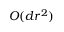<formula> <loc_0><loc_0><loc_500><loc_500>O ( d r ^ { 2 } )</formula> 